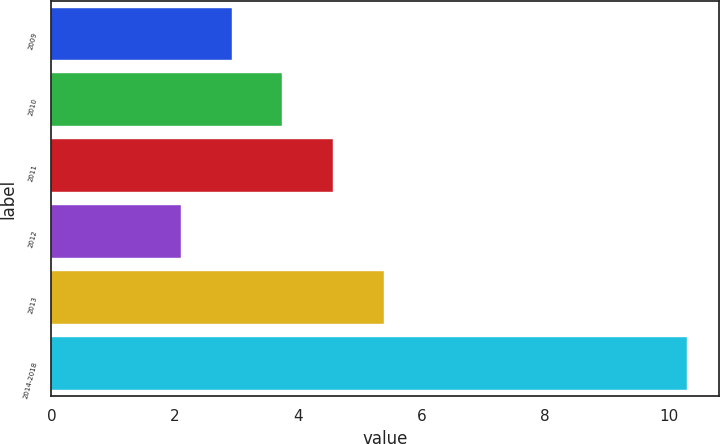<chart> <loc_0><loc_0><loc_500><loc_500><bar_chart><fcel>2009<fcel>2010<fcel>2011<fcel>2012<fcel>2013<fcel>2014-2018<nl><fcel>2.92<fcel>3.74<fcel>4.56<fcel>2.1<fcel>5.38<fcel>10.3<nl></chart> 